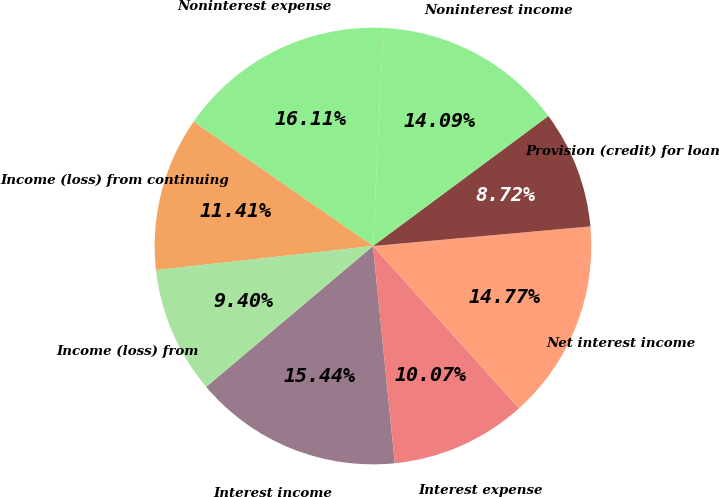Convert chart. <chart><loc_0><loc_0><loc_500><loc_500><pie_chart><fcel>Interest income<fcel>Interest expense<fcel>Net interest income<fcel>Provision (credit) for loan<fcel>Noninterest income<fcel>Noninterest expense<fcel>Income (loss) from continuing<fcel>Income (loss) from<nl><fcel>15.44%<fcel>10.07%<fcel>14.77%<fcel>8.72%<fcel>14.09%<fcel>16.11%<fcel>11.41%<fcel>9.4%<nl></chart> 